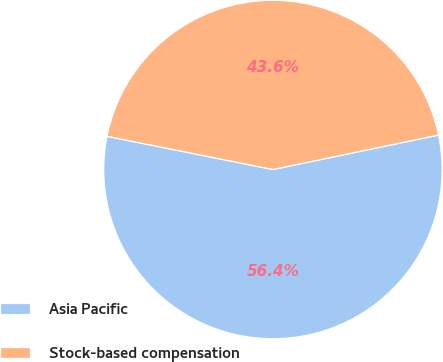Convert chart to OTSL. <chart><loc_0><loc_0><loc_500><loc_500><pie_chart><fcel>Asia Pacific<fcel>Stock-based compensation<nl><fcel>56.41%<fcel>43.59%<nl></chart> 